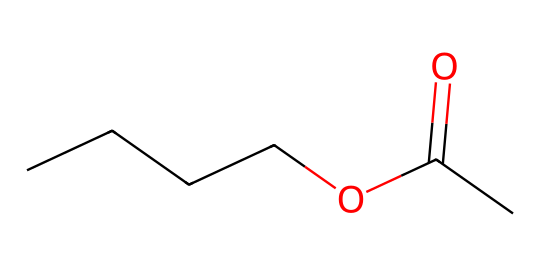how many carbon atoms are in butyl acetate? By analyzing the SMILES representation "CCCCOC(=O)C", we can count the carbon (C) atoms. There are five carbon atoms in total: four from the "CCCC" part and one from "C" after the carbonyl group.
Answer: five what functional group is present in butyl acetate? The SMILES structure shows a carbonyl (C=O) adjacent to an alkoxy (—O—) group, which is characteristic of esters. Thus, the functional group present is the ester group.
Answer: ester how many oxygen atoms are present in the structure? The SMILES representation indicates one oxygen atom in the alkoxy part and one oxygen in the carbonyl part (C=O). Therefore, adding these together, there are two oxygen atoms in total.
Answer: two describe the length of the carbon chain in butyl acetate. The chain represented by "CCCC" indicates a straight-chain configuration with four carbon atoms connected sequentially. Thus, the carbon chain length is four carbons.
Answer: four carbons which atom connects the carbon chain to the ester functional group? Examining the structure, the oxygen atom (O) connects the carbon chain (CCCC) to the ester functional group (C(=O)), serving as the link between them.
Answer: oxygen what is the molecular formula of butyl acetate? From the structure analysis, we have 5 carbons (C), 10 hydrogens (H), and 2 oxygens (O). Therefore, the molecular formula is C5H10O2.
Answer: C5H10O2 how does the presence of the ester group affect the solubility of butyl acetate? The ester functional group introduces polarity to the molecule, allowing it to mix with both polar and nonpolar solvents. This enhances its solubility compared to hydrocarbons alone.
Answer: enhances solubility 